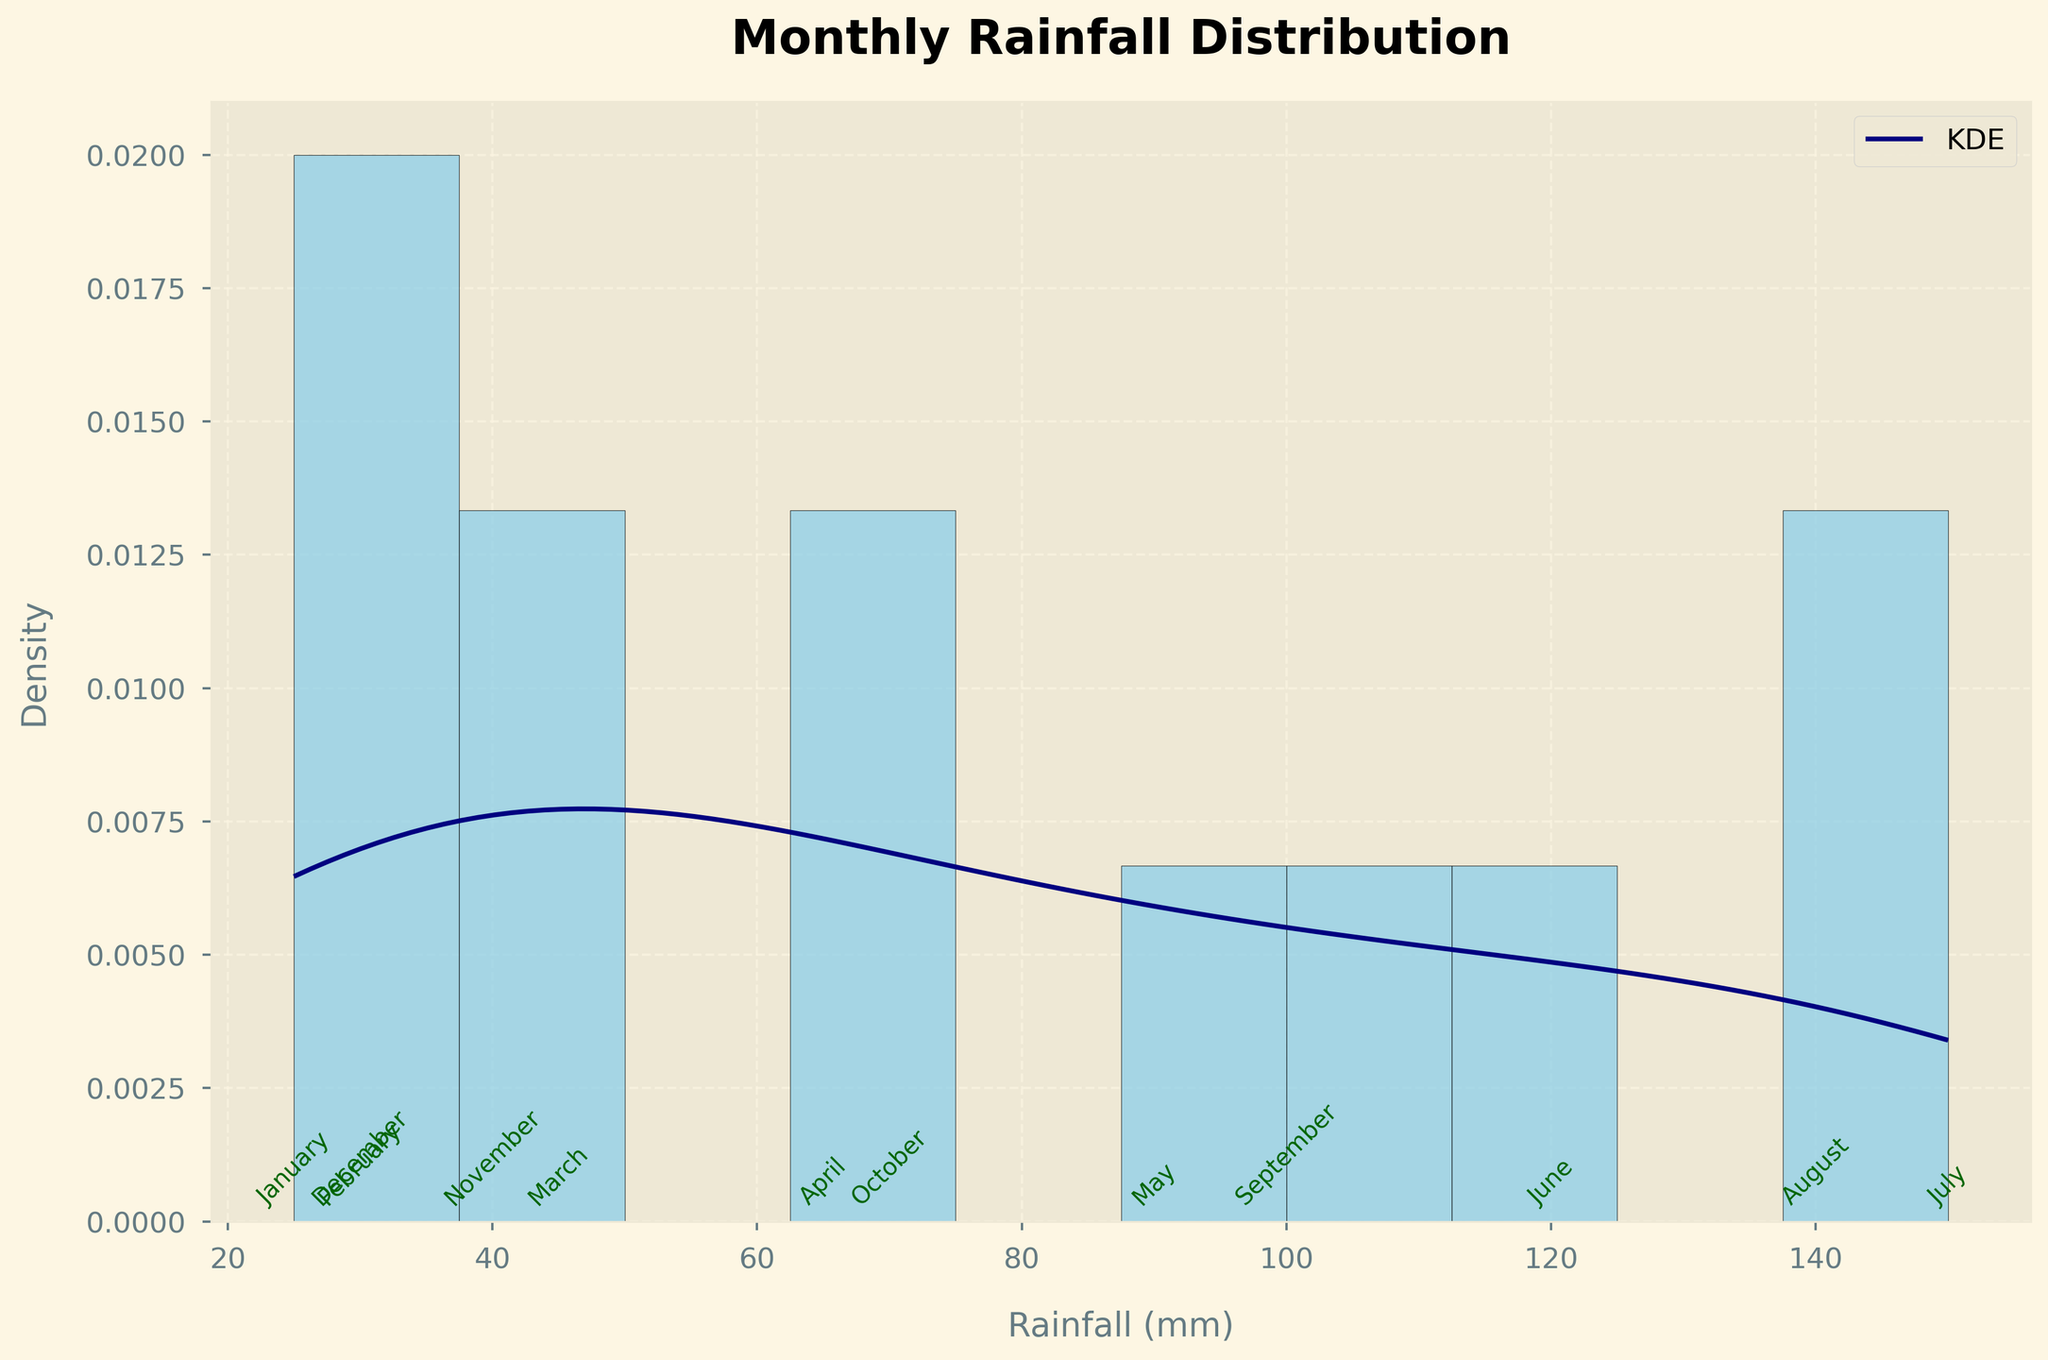What is the title of the figure? The title of the figure is displayed at the top and it reads "Monthly Rainfall Distribution".
Answer: Monthly Rainfall Distribution What does the x-axis represent? The x-axis represents the amount of rainfall in millimeters.
Answer: Rainfall (mm) How many rainfall bins are there in the histogram? There are 10 bins in the histogram, you can count them by looking at each grouped bar section.
Answer: 10 Which month has the highest rainfall and what is the amount? By looking at the text annotations aligned to the data points, July has the highest rainfall amounting to 150 mm.
Answer: July, 150 mm What is the range of rainfall values for the months provided? The minimum value is 25 mm (occurs in January), and the maximum value is 150 mm (occurs in July), so the range is 150 mm - 25 mm.
Answer: 125 mm Which months have rainfall amounts below 50 mm? According to the text annotations, January (25 mm), February (30 mm), and December (30 mm) have rainfall amounts below 50 mm.
Answer: January, February, December What is the peak density value on the KDE curve? By observing the KDE (density) curve, the peak occurs slightly above the 100 mm mark.
Answer: Slightly above 100 mm Compare the rainfall in August and September, which one has more? From the text annotations, August has 140 mm of rainfall while September has 100 mm. Therefore, August has more rainfall.
Answer: August How does the density of rainfall change as it increases from 25 mm to 150 mm? The KDE curve shows that the density increases as rainfall moves from 25 mm towards 100 mm, peaks slightly above 100 mm, and then decreases as it approaches 150 mm.
Answer: Increases, peaks near 100 mm, decreases What is the average rainfall amount for the months of May, June, and July? May has 90 mm, June 120 mm, and July 150 mm. Summing these up gives 360 mm. To find the average: 360 mm / 3 = 120 mm.
Answer: 120 mm 